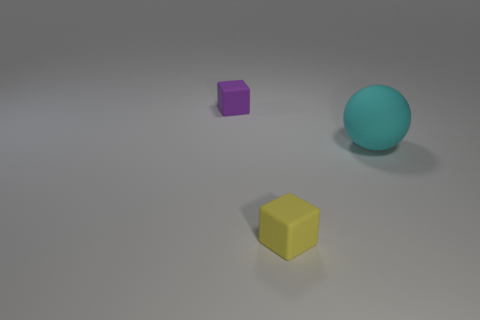Add 1 brown metallic blocks. How many objects exist? 4 Subtract all balls. How many objects are left? 2 Add 3 small purple objects. How many small purple objects are left? 4 Add 3 purple matte balls. How many purple matte balls exist? 3 Subtract 0 purple spheres. How many objects are left? 3 Subtract all yellow cubes. Subtract all blue rubber blocks. How many objects are left? 2 